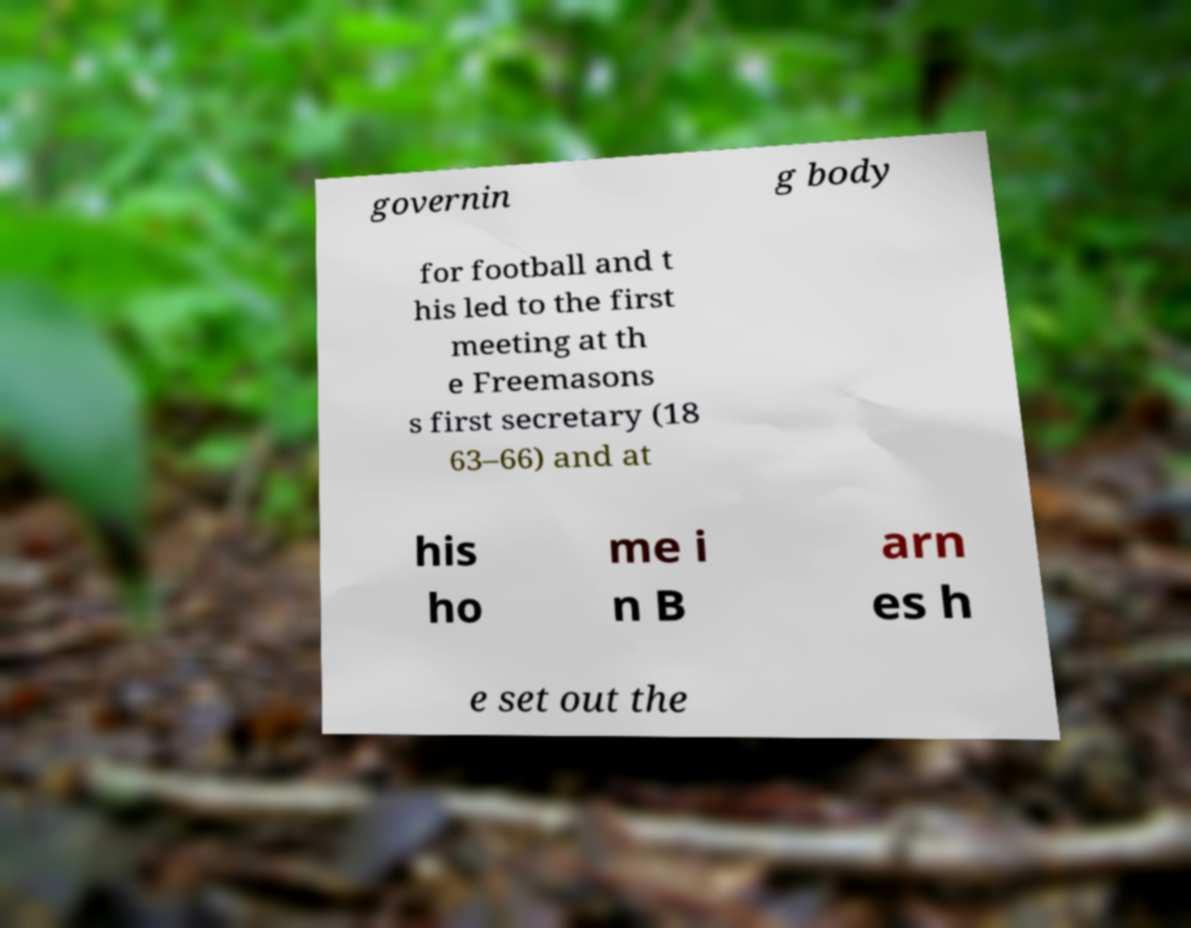Could you assist in decoding the text presented in this image and type it out clearly? governin g body for football and t his led to the first meeting at th e Freemasons s first secretary (18 63–66) and at his ho me i n B arn es h e set out the 